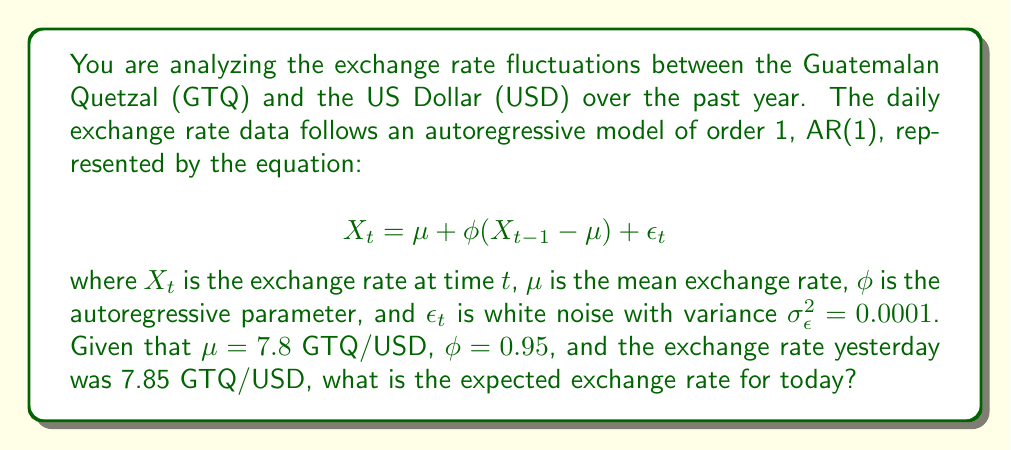Help me with this question. To solve this problem, we need to use the given AR(1) model equation and plug in the known values. Let's break it down step by step:

1. We are given the AR(1) model equation:
   $$ X_t = \mu + \phi(X_{t-1} - \mu) + \epsilon_t $$

2. We know the following parameters:
   - $\mu = 7.8$ GTQ/USD (mean exchange rate)
   - $\phi = 0.95$ (autoregressive parameter)
   - $X_{t-1} = 7.85$ GTQ/USD (yesterday's exchange rate)

3. We need to find $X_t$, which is today's expected exchange rate. Since we're calculating the expected value, we can ignore the error term $\epsilon_t$ as its expected value is zero.

4. Let's substitute the known values into the equation:
   $$ E[X_t] = 7.8 + 0.95(7.85 - 7.8) $$

5. Simplify the expression inside the parentheses:
   $$ E[X_t] = 7.8 + 0.95(0.05) $$

6. Multiply 0.95 and 0.05:
   $$ E[X_t] = 7.8 + 0.0475 $$

7. Add the results:
   $$ E[X_t] = 7.8475 $$

Therefore, the expected exchange rate for today is 7.8475 GTQ/USD.
Answer: 7.8475 GTQ/USD 